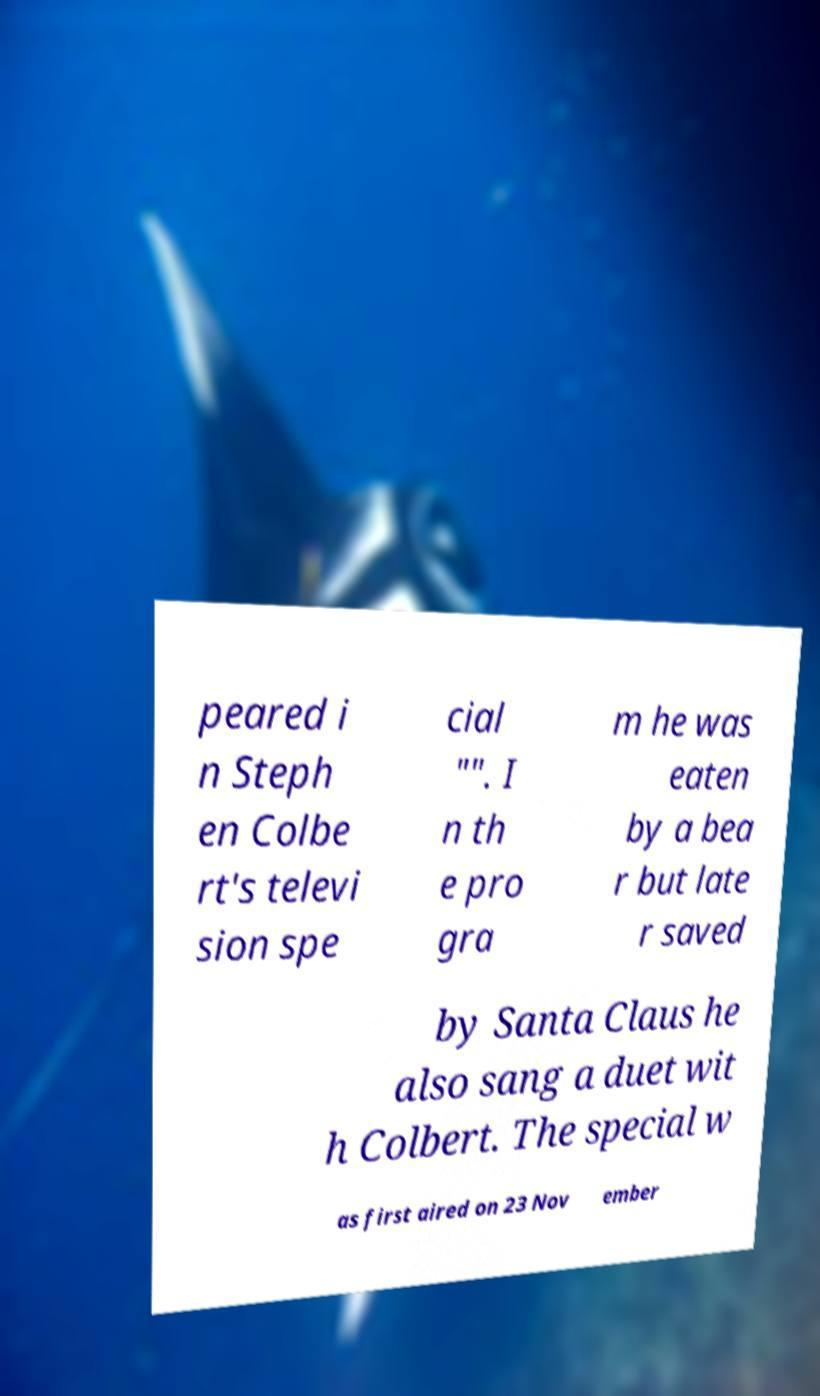What messages or text are displayed in this image? I need them in a readable, typed format. peared i n Steph en Colbe rt's televi sion spe cial "". I n th e pro gra m he was eaten by a bea r but late r saved by Santa Claus he also sang a duet wit h Colbert. The special w as first aired on 23 Nov ember 